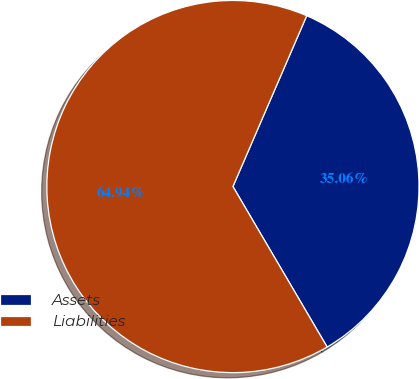Convert chart. <chart><loc_0><loc_0><loc_500><loc_500><pie_chart><fcel>Assets<fcel>Liabilities<nl><fcel>35.06%<fcel>64.94%<nl></chart> 